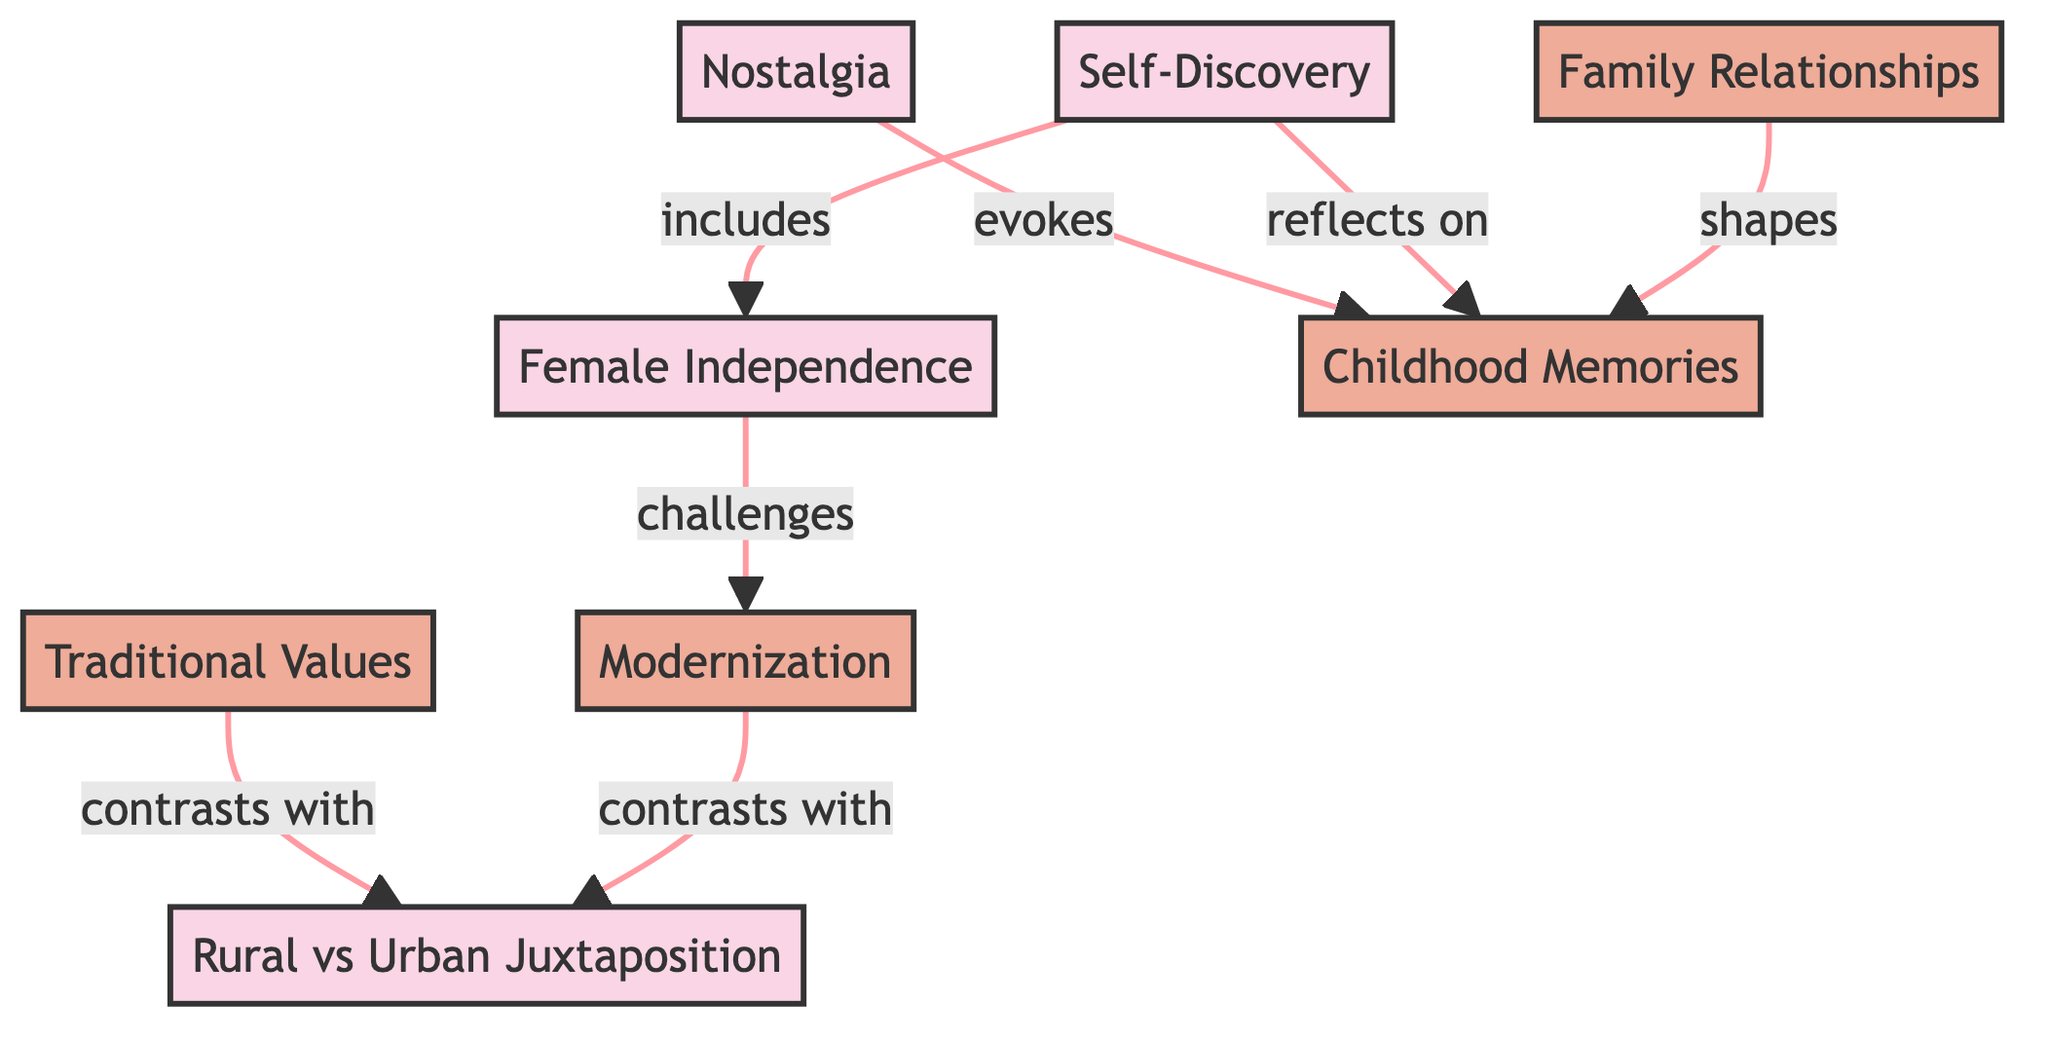What theme is connected to childhood memories through evocation? The diagram shows a direct connection from the node "Nostalgia" to "Childhood Memories," with the label indicating that nostalgia evokes childhood memories.
Answer: Nostalgia How many nodes are present in the diagram? Counting the unique elements in the nodes section, there are a total of 8 nodes representing various themes and motifs.
Answer: 8 What is the relationship between self-discovery and female independence? The diagram indicates a connection from "Self-Discovery" to "Female Independence," labeled as "includes," suggesting that the theme of self-discovery encompasses aspects of female independence.
Answer: includes Which motif does the traditional values theme contrast with? According to the diagram, "Traditional Values" contrasts with "Rural vs Urban Juxtaposition," as indicated by the connection labeled "contrasts with."
Answer: Rural vs Urban Juxtaposition Which theme reflects on childhood memories? The diagram explicitly shows a connection from "Self-Discovery" to "Childhood Memories," labeled as "reflects on," indicating that self-discovery involves reflection on childhood memories.
Answer: Self-Discovery How is female independence related to modernization? The diagram shows a direct link from "Female Independence" to "Modernization," labeled "challenges," indicating that female independence challenges aspects of modernization.
Answer: challenges What motif shapes childhood memories? The relationship depicted in the diagram shows "Family Relationships" shaping "Childhood Memories," as indicated by the connection labeled "shapes."
Answer: Family Relationships How many edges are there in the diagram? By counting the connections (edges) listed, there are 7 edges connecting various nodes in the diagram, indicating relationships between the themes and motifs.
Answer: 7 